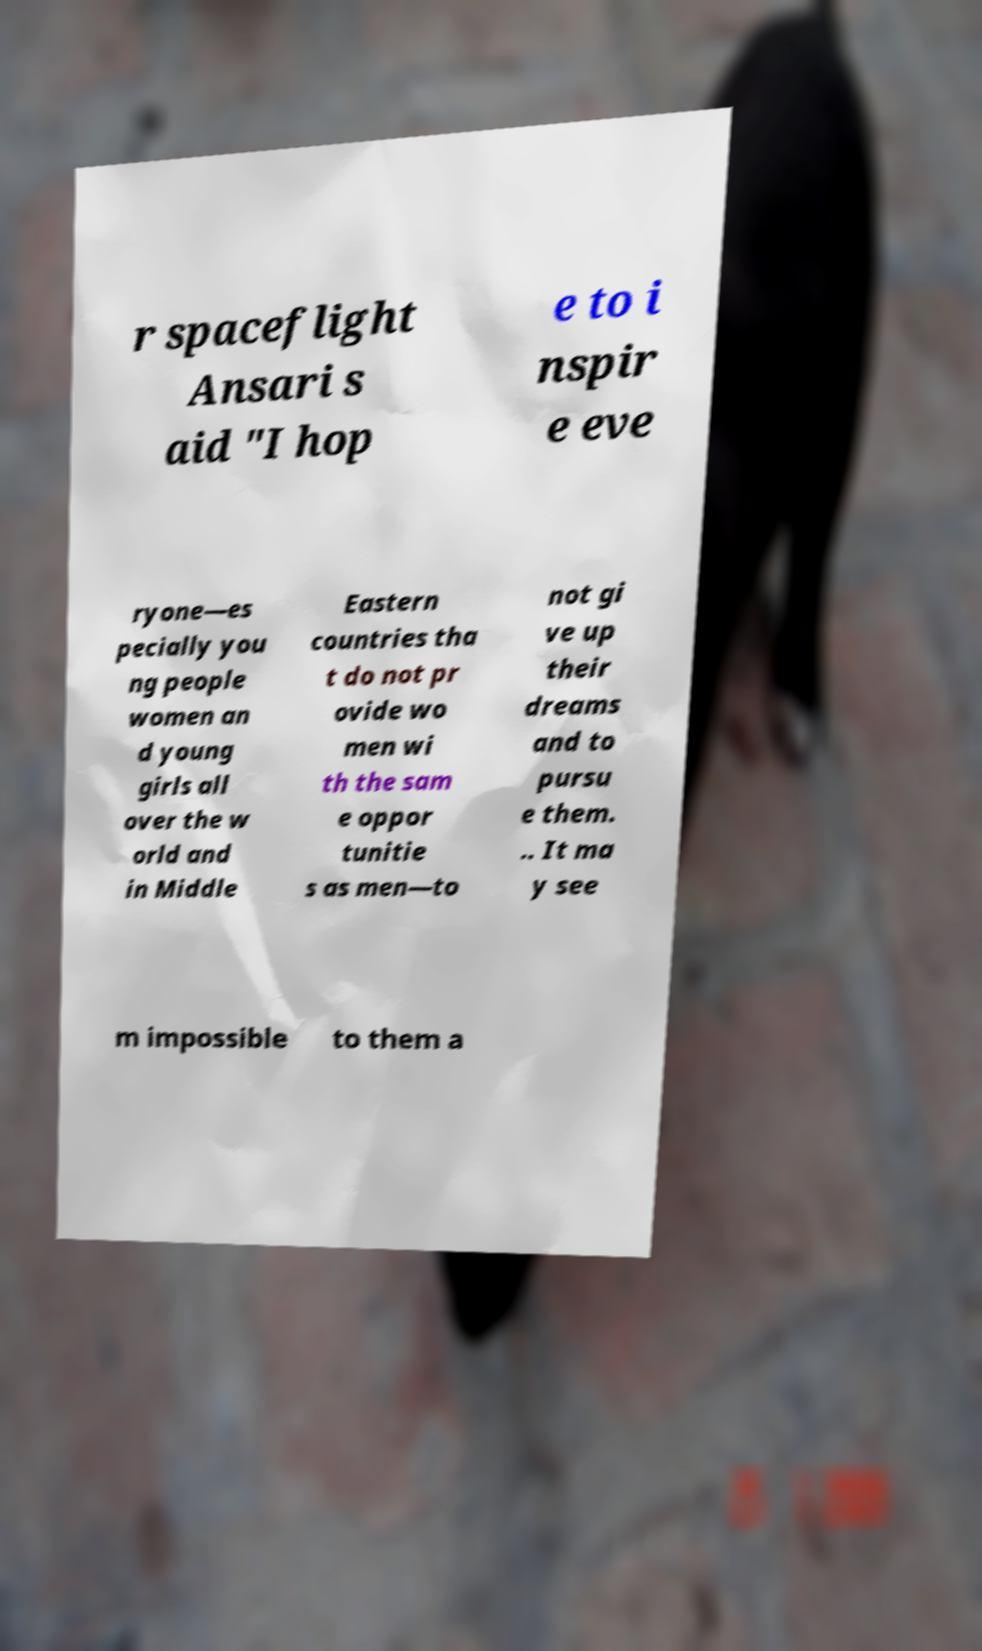For documentation purposes, I need the text within this image transcribed. Could you provide that? r spaceflight Ansari s aid "I hop e to i nspir e eve ryone—es pecially you ng people women an d young girls all over the w orld and in Middle Eastern countries tha t do not pr ovide wo men wi th the sam e oppor tunitie s as men—to not gi ve up their dreams and to pursu e them. .. It ma y see m impossible to them a 